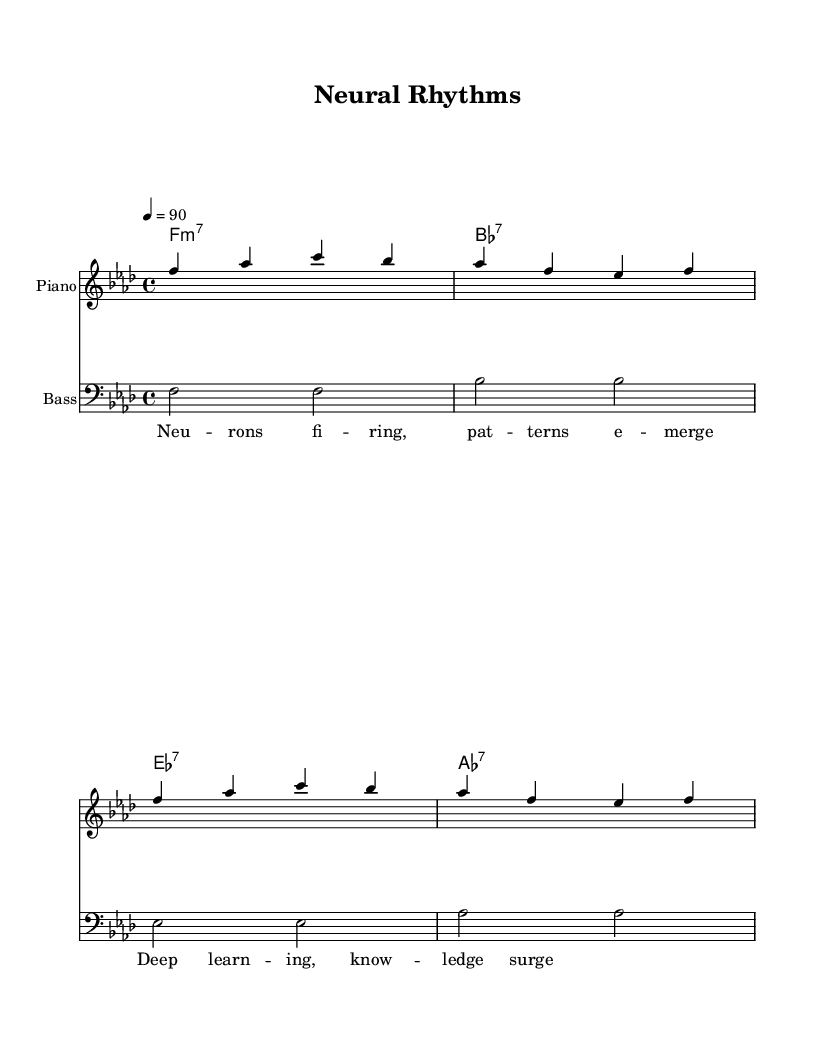What is the key signature of this music? The key signature is indicated by the presence of B flat and E flat, which suggests F minor.
Answer: F minor What is the time signature of this piece? The time signature is shown at the beginning of the staff and is represented as a fraction; in this case, it shows four beats per measure.
Answer: 4/4 What is the tempo marking given? The tempo marking is indicated above the staff; it specifies the speed of the piece, which is set to 90 beats per minute.
Answer: 90 How many measures are in the melody? By counting the groups of four beats in the melody section, we identify that there are four complete measures displaying the melody.
Answer: 4 What type of chord follows the bass note F? The bass note F is accompanied by a chord symbol indicating that it is an F minor seventh chord, as shown in the harmonies section.
Answer: F:m7 What do the lyrics suggest about the theme of the song? The lyrics reflect technological concepts, such as deep learning and patterns emerging, resonating with themes of artificial intelligence and machine learning.
Answer: Artificial intelligence Which instrument is primarily featured in this score? The score explicitly names one staff as "Piano," indicating that the main instrument featured is the piano.
Answer: Piano 